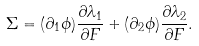Convert formula to latex. <formula><loc_0><loc_0><loc_500><loc_500>\Sigma = ( \partial _ { 1 } \phi ) \frac { \partial \lambda _ { 1 } } { \partial F } + ( \partial _ { 2 } \phi ) \frac { \partial \lambda _ { 2 } } { \partial F } .</formula> 